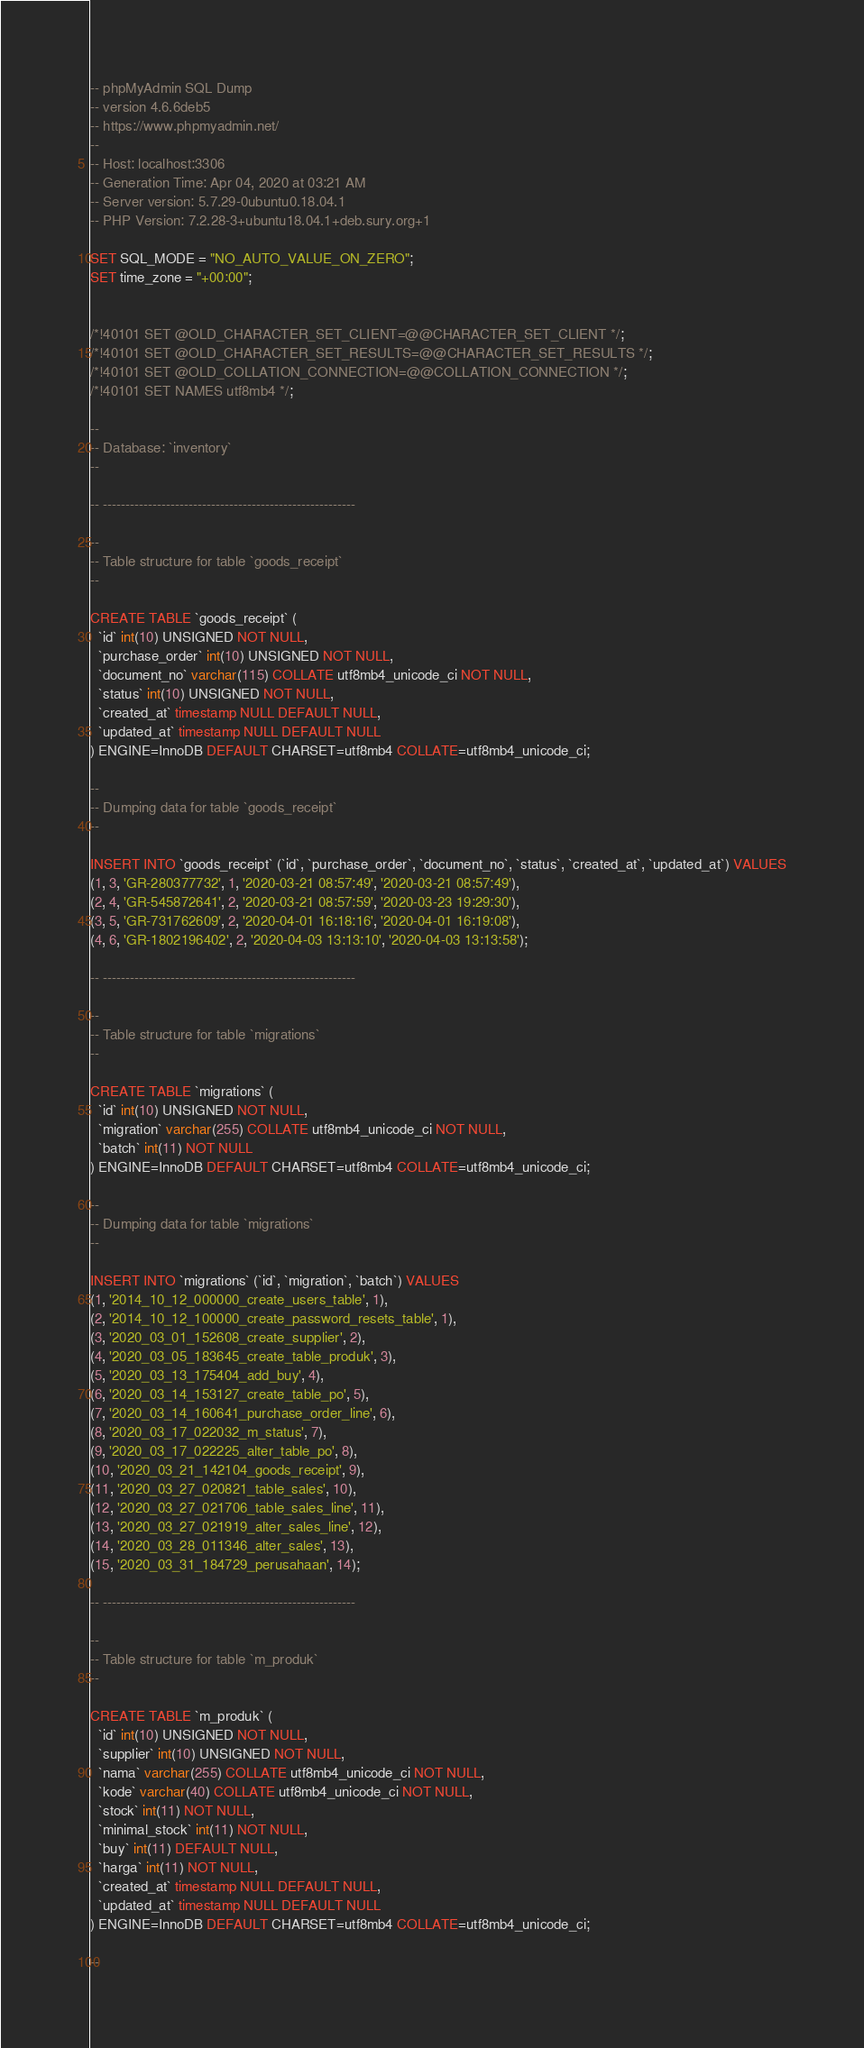<code> <loc_0><loc_0><loc_500><loc_500><_SQL_>-- phpMyAdmin SQL Dump
-- version 4.6.6deb5
-- https://www.phpmyadmin.net/
--
-- Host: localhost:3306
-- Generation Time: Apr 04, 2020 at 03:21 AM
-- Server version: 5.7.29-0ubuntu0.18.04.1
-- PHP Version: 7.2.28-3+ubuntu18.04.1+deb.sury.org+1

SET SQL_MODE = "NO_AUTO_VALUE_ON_ZERO";
SET time_zone = "+00:00";


/*!40101 SET @OLD_CHARACTER_SET_CLIENT=@@CHARACTER_SET_CLIENT */;
/*!40101 SET @OLD_CHARACTER_SET_RESULTS=@@CHARACTER_SET_RESULTS */;
/*!40101 SET @OLD_COLLATION_CONNECTION=@@COLLATION_CONNECTION */;
/*!40101 SET NAMES utf8mb4 */;

--
-- Database: `inventory`
--

-- --------------------------------------------------------

--
-- Table structure for table `goods_receipt`
--

CREATE TABLE `goods_receipt` (
  `id` int(10) UNSIGNED NOT NULL,
  `purchase_order` int(10) UNSIGNED NOT NULL,
  `document_no` varchar(115) COLLATE utf8mb4_unicode_ci NOT NULL,
  `status` int(10) UNSIGNED NOT NULL,
  `created_at` timestamp NULL DEFAULT NULL,
  `updated_at` timestamp NULL DEFAULT NULL
) ENGINE=InnoDB DEFAULT CHARSET=utf8mb4 COLLATE=utf8mb4_unicode_ci;

--
-- Dumping data for table `goods_receipt`
--

INSERT INTO `goods_receipt` (`id`, `purchase_order`, `document_no`, `status`, `created_at`, `updated_at`) VALUES
(1, 3, 'GR-280377732', 1, '2020-03-21 08:57:49', '2020-03-21 08:57:49'),
(2, 4, 'GR-545872641', 2, '2020-03-21 08:57:59', '2020-03-23 19:29:30'),
(3, 5, 'GR-731762609', 2, '2020-04-01 16:18:16', '2020-04-01 16:19:08'),
(4, 6, 'GR-1802196402', 2, '2020-04-03 13:13:10', '2020-04-03 13:13:58');

-- --------------------------------------------------------

--
-- Table structure for table `migrations`
--

CREATE TABLE `migrations` (
  `id` int(10) UNSIGNED NOT NULL,
  `migration` varchar(255) COLLATE utf8mb4_unicode_ci NOT NULL,
  `batch` int(11) NOT NULL
) ENGINE=InnoDB DEFAULT CHARSET=utf8mb4 COLLATE=utf8mb4_unicode_ci;

--
-- Dumping data for table `migrations`
--

INSERT INTO `migrations` (`id`, `migration`, `batch`) VALUES
(1, '2014_10_12_000000_create_users_table', 1),
(2, '2014_10_12_100000_create_password_resets_table', 1),
(3, '2020_03_01_152608_create_supplier', 2),
(4, '2020_03_05_183645_create_table_produk', 3),
(5, '2020_03_13_175404_add_buy', 4),
(6, '2020_03_14_153127_create_table_po', 5),
(7, '2020_03_14_160641_purchase_order_line', 6),
(8, '2020_03_17_022032_m_status', 7),
(9, '2020_03_17_022225_alter_table_po', 8),
(10, '2020_03_21_142104_goods_receipt', 9),
(11, '2020_03_27_020821_table_sales', 10),
(12, '2020_03_27_021706_table_sales_line', 11),
(13, '2020_03_27_021919_alter_sales_line', 12),
(14, '2020_03_28_011346_alter_sales', 13),
(15, '2020_03_31_184729_perusahaan', 14);

-- --------------------------------------------------------

--
-- Table structure for table `m_produk`
--

CREATE TABLE `m_produk` (
  `id` int(10) UNSIGNED NOT NULL,
  `supplier` int(10) UNSIGNED NOT NULL,
  `nama` varchar(255) COLLATE utf8mb4_unicode_ci NOT NULL,
  `kode` varchar(40) COLLATE utf8mb4_unicode_ci NOT NULL,
  `stock` int(11) NOT NULL,
  `minimal_stock` int(11) NOT NULL,
  `buy` int(11) DEFAULT NULL,
  `harga` int(11) NOT NULL,
  `created_at` timestamp NULL DEFAULT NULL,
  `updated_at` timestamp NULL DEFAULT NULL
) ENGINE=InnoDB DEFAULT CHARSET=utf8mb4 COLLATE=utf8mb4_unicode_ci;

--</code> 